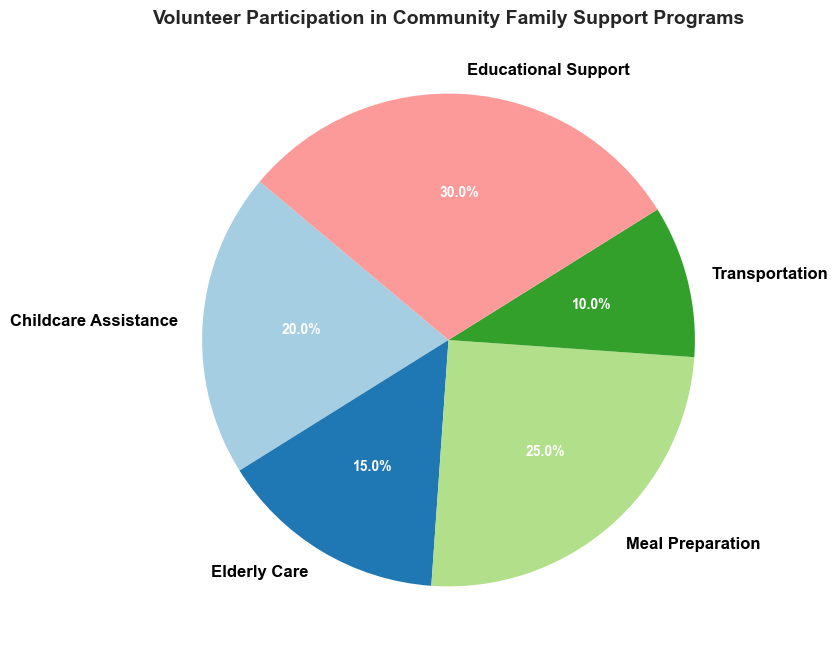Which category has the highest percentage of volunteer participation? By looking at the pie chart, the largest slice represents the category with the highest percentage. The Educational Support segment appears largest with 30%.
Answer: Educational Support Which category has the smallest percentage of volunteer participation? By identifying the smallest slice of the pie chart, it is apparent that Transportation has the smallest percentage at 10%.
Answer: Transportation What is the combined percentage of volunteer participation for Childcare Assistance and Elderly Care? Sum the percentages of Childcare Assistance (20%) and Elderly Care (15%). 20% + 15% = 35%.
Answer: 35% How much more volunteer participation does Meal Preparation have compared to Transportation? Subtract the percentage of Transportation (10%) from Meal Preparation (25%). 25% - 10% = 15%.
Answer: 15% Is Educational Support more popular than all other categories combined? First, sum the percentages of all other categories: 20% (Childcare Assistance) + 15% (Elderly Care) + 25% (Meal Preparation) + 10% (Transportation) = 70%. Since 70% is more than 30% for Educational Support, it is less popular.
Answer: No Which category's slice is displayed in the brightest color? By examining the colors used, the brightest-colored slice corresponds to Educational Support.
Answer: Educational Support What is the average percentage of volunteer participation across all categories? Sum all the categories' percentages: 20 + 15 + 25 + 10 + 30 = 100. There are 5 categories, so the average is 100 / 5 = 20%.
Answer: 20% Does Meal Preparation have a higher volunteer participation percentage than Elderly Care? Compare the percentages: Meal Preparation is at 25% and Elderly Care is at 15%. Since 25% > 15%, Meal Preparation has a higher participation rate.
Answer: Yes How much higher is Educational Support's volunteer participation compared to Elderly Care and Transportation combined? Combine Elderly Care (15%) and Transportation (10%): 15 + 10 = 25%. Then subtract this total from Educational Support’s percentage: 30% - 25% = 5%.
Answer: 5% Which two categories, when combined, nearly equal the participation percentage of Educational Support? Educational Support has 30%. Combine Childcare Assistance (20%) and Transportation (10%): 20 + 10 = 30%. Childcare Assistance and Transportation combined nearly equal Educational Support.
Answer: Childcare Assistance and Transportation 